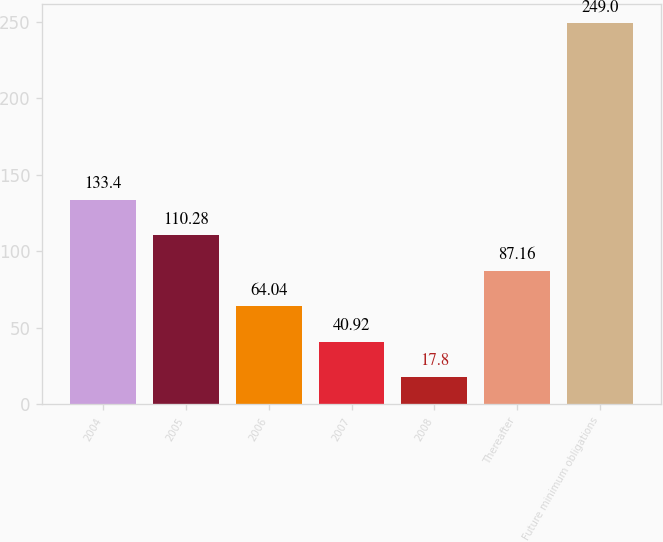Convert chart to OTSL. <chart><loc_0><loc_0><loc_500><loc_500><bar_chart><fcel>2004<fcel>2005<fcel>2006<fcel>2007<fcel>2008<fcel>Thereafter<fcel>Future minimum obligations<nl><fcel>133.4<fcel>110.28<fcel>64.04<fcel>40.92<fcel>17.8<fcel>87.16<fcel>249<nl></chart> 